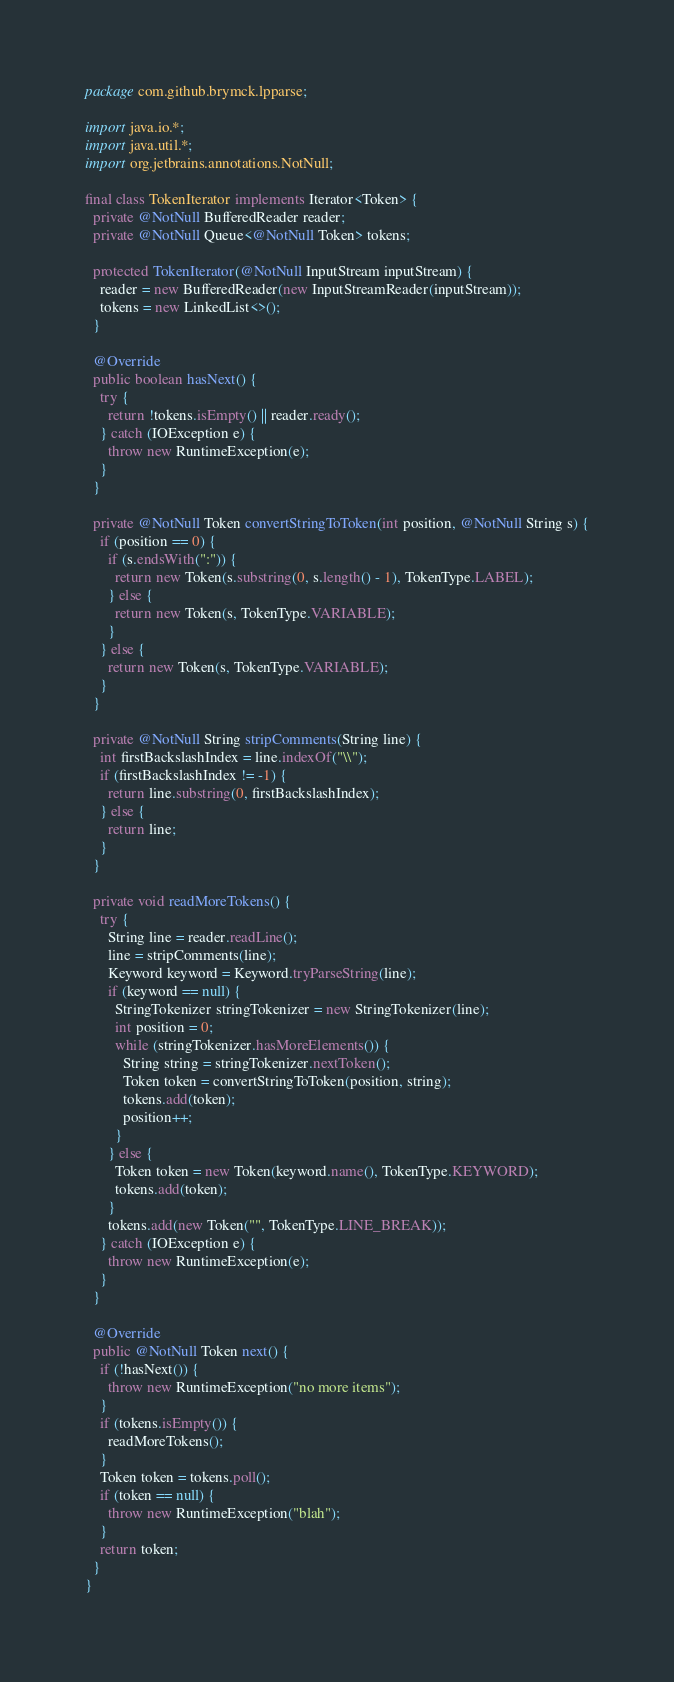<code> <loc_0><loc_0><loc_500><loc_500><_Java_>package com.github.brymck.lpparse;

import java.io.*;
import java.util.*;
import org.jetbrains.annotations.NotNull;

final class TokenIterator implements Iterator<Token> {
  private @NotNull BufferedReader reader;
  private @NotNull Queue<@NotNull Token> tokens;

  protected TokenIterator(@NotNull InputStream inputStream) {
    reader = new BufferedReader(new InputStreamReader(inputStream));
    tokens = new LinkedList<>();
  }

  @Override
  public boolean hasNext() {
    try {
      return !tokens.isEmpty() || reader.ready();
    } catch (IOException e) {
      throw new RuntimeException(e);
    }
  }

  private @NotNull Token convertStringToToken(int position, @NotNull String s) {
    if (position == 0) {
      if (s.endsWith(":")) {
        return new Token(s.substring(0, s.length() - 1), TokenType.LABEL);
      } else {
        return new Token(s, TokenType.VARIABLE);
      }
    } else {
      return new Token(s, TokenType.VARIABLE);
    }
  }

  private @NotNull String stripComments(String line) {
    int firstBackslashIndex = line.indexOf("\\");
    if (firstBackslashIndex != -1) {
      return line.substring(0, firstBackslashIndex);
    } else {
      return line;
    }
  }

  private void readMoreTokens() {
    try {
      String line = reader.readLine();
      line = stripComments(line);
      Keyword keyword = Keyword.tryParseString(line);
      if (keyword == null) {
        StringTokenizer stringTokenizer = new StringTokenizer(line);
        int position = 0;
        while (stringTokenizer.hasMoreElements()) {
          String string = stringTokenizer.nextToken();
          Token token = convertStringToToken(position, string);
          tokens.add(token);
          position++;
        }
      } else {
        Token token = new Token(keyword.name(), TokenType.KEYWORD);
        tokens.add(token);
      }
      tokens.add(new Token("", TokenType.LINE_BREAK));
    } catch (IOException e) {
      throw new RuntimeException(e);
    }
  }

  @Override
  public @NotNull Token next() {
    if (!hasNext()) {
      throw new RuntimeException("no more items");
    }
    if (tokens.isEmpty()) {
      readMoreTokens();
    }
    Token token = tokens.poll();
    if (token == null) {
      throw new RuntimeException("blah");
    }
    return token;
  }
}
</code> 